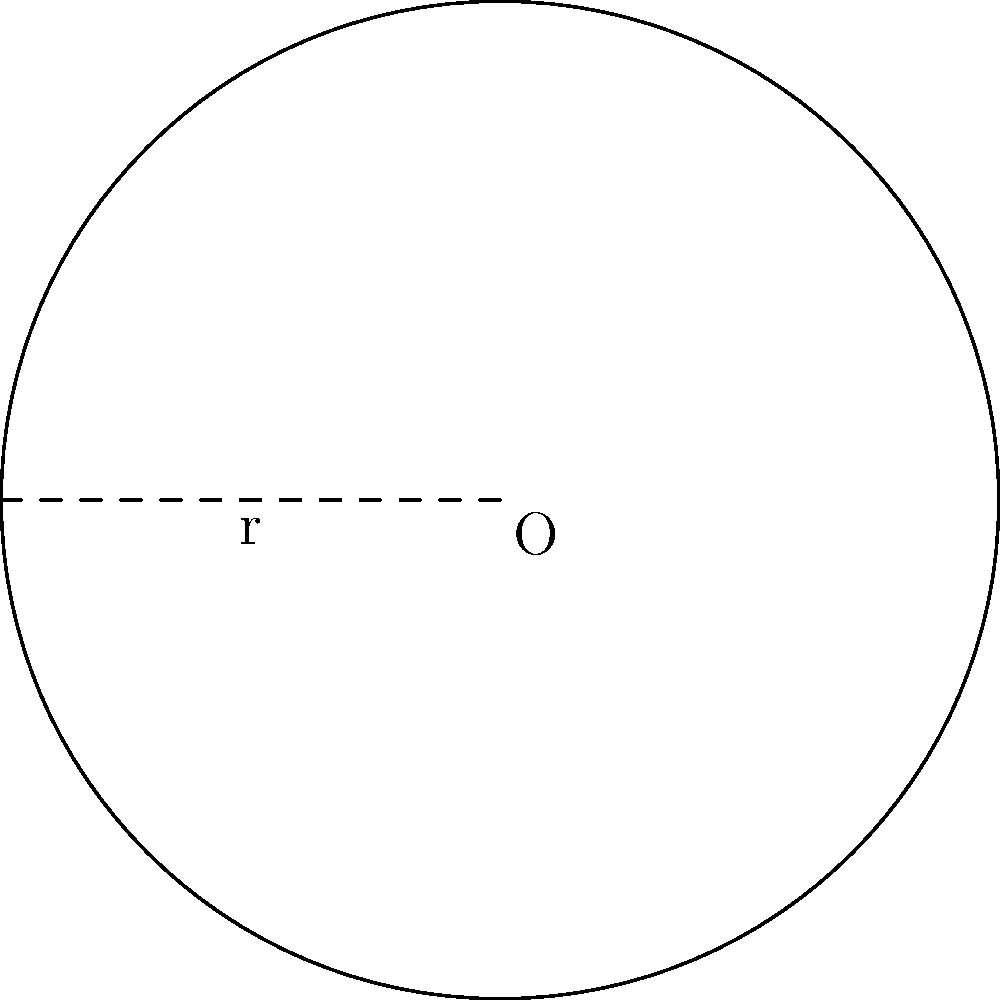You're visiting a trendy coffee shop known for its unique circular tables. The barista mentions that each table has a radius of 2 feet. What is the perimeter of one of these coffee tables? To find the perimeter of a circular coffee table, we need to calculate its circumference. The formula for the circumference of a circle is:

$$C = 2\pi r$$

Where:
$C$ = circumference (perimeter)
$\pi$ = pi (approximately 3.14159)
$r$ = radius

Given:
$r = 2$ feet

Let's substitute these values into the formula:

$$C = 2\pi(2)$$
$$C = 4\pi$$

Now, let's calculate the result:
$$C = 4 * 3.14159$$
$$C \approx 12.57 \text{ feet}$$

Therefore, the perimeter of the circular coffee table is approximately 12.57 feet.
Answer: $12.57 \text{ feet}$ 